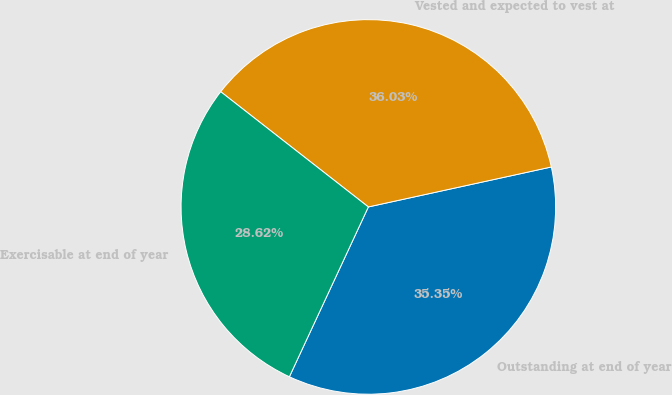<chart> <loc_0><loc_0><loc_500><loc_500><pie_chart><fcel>Outstanding at end of year<fcel>Vested and expected to vest at<fcel>Exercisable at end of year<nl><fcel>35.35%<fcel>36.03%<fcel>28.62%<nl></chart> 